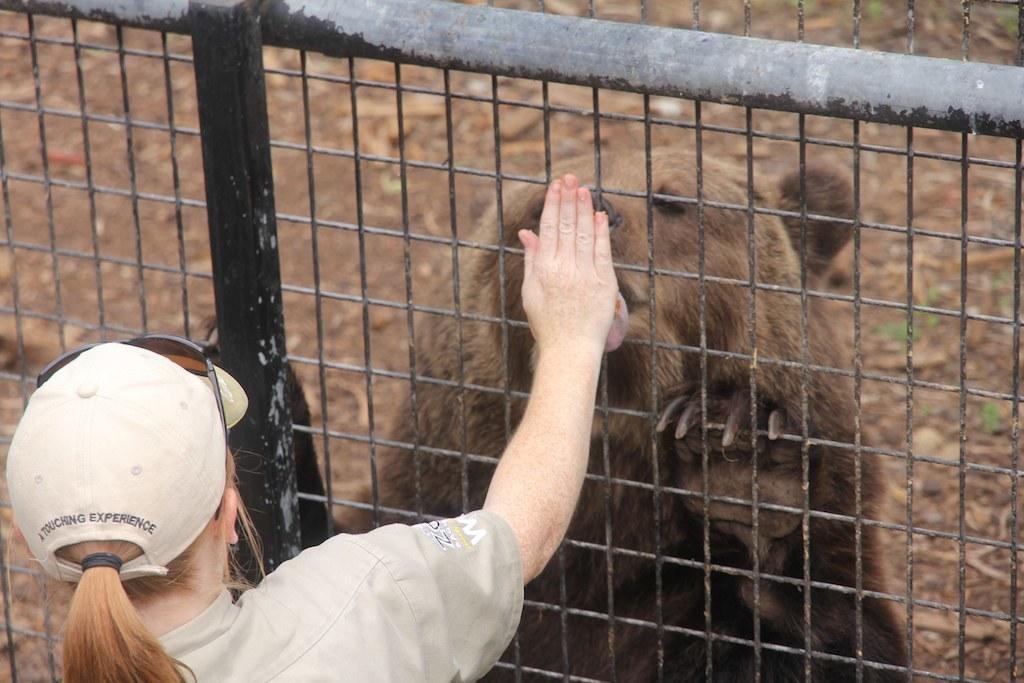Can you describe this image briefly? In this image there is a woman wearing hat and glasses, in front of her there is a fencing, behind the fencing there is a bear. 